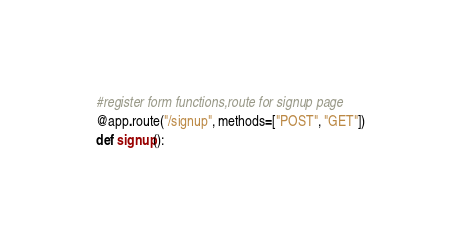Convert code to text. <code><loc_0><loc_0><loc_500><loc_500><_Python_>#register form functions,route for signup page
@app.route("/signup", methods=["POST", "GET"])
def signup():</code> 